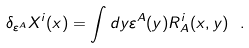Convert formula to latex. <formula><loc_0><loc_0><loc_500><loc_500>\delta _ { \varepsilon ^ { A } } X ^ { i } ( x ) = \int d y \varepsilon ^ { A } ( y ) R ^ { i } _ { A } ( x , y ) \ .</formula> 